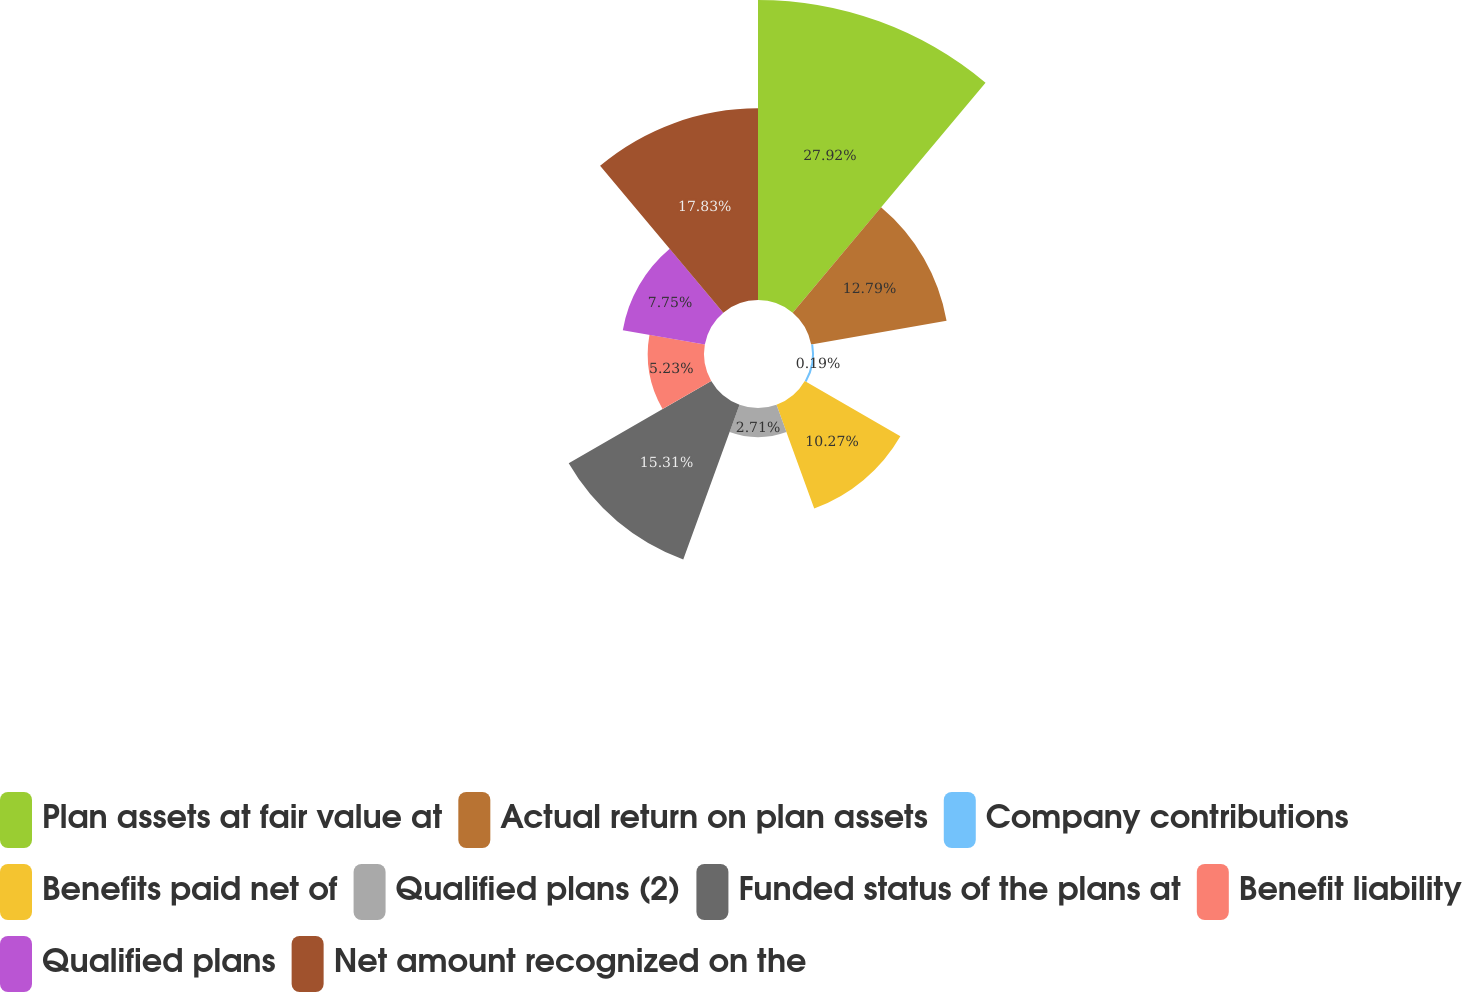<chart> <loc_0><loc_0><loc_500><loc_500><pie_chart><fcel>Plan assets at fair value at<fcel>Actual return on plan assets<fcel>Company contributions<fcel>Benefits paid net of<fcel>Qualified plans (2)<fcel>Funded status of the plans at<fcel>Benefit liability<fcel>Qualified plans<fcel>Net amount recognized on the<nl><fcel>27.91%<fcel>12.79%<fcel>0.19%<fcel>10.27%<fcel>2.71%<fcel>15.31%<fcel>5.23%<fcel>7.75%<fcel>17.83%<nl></chart> 